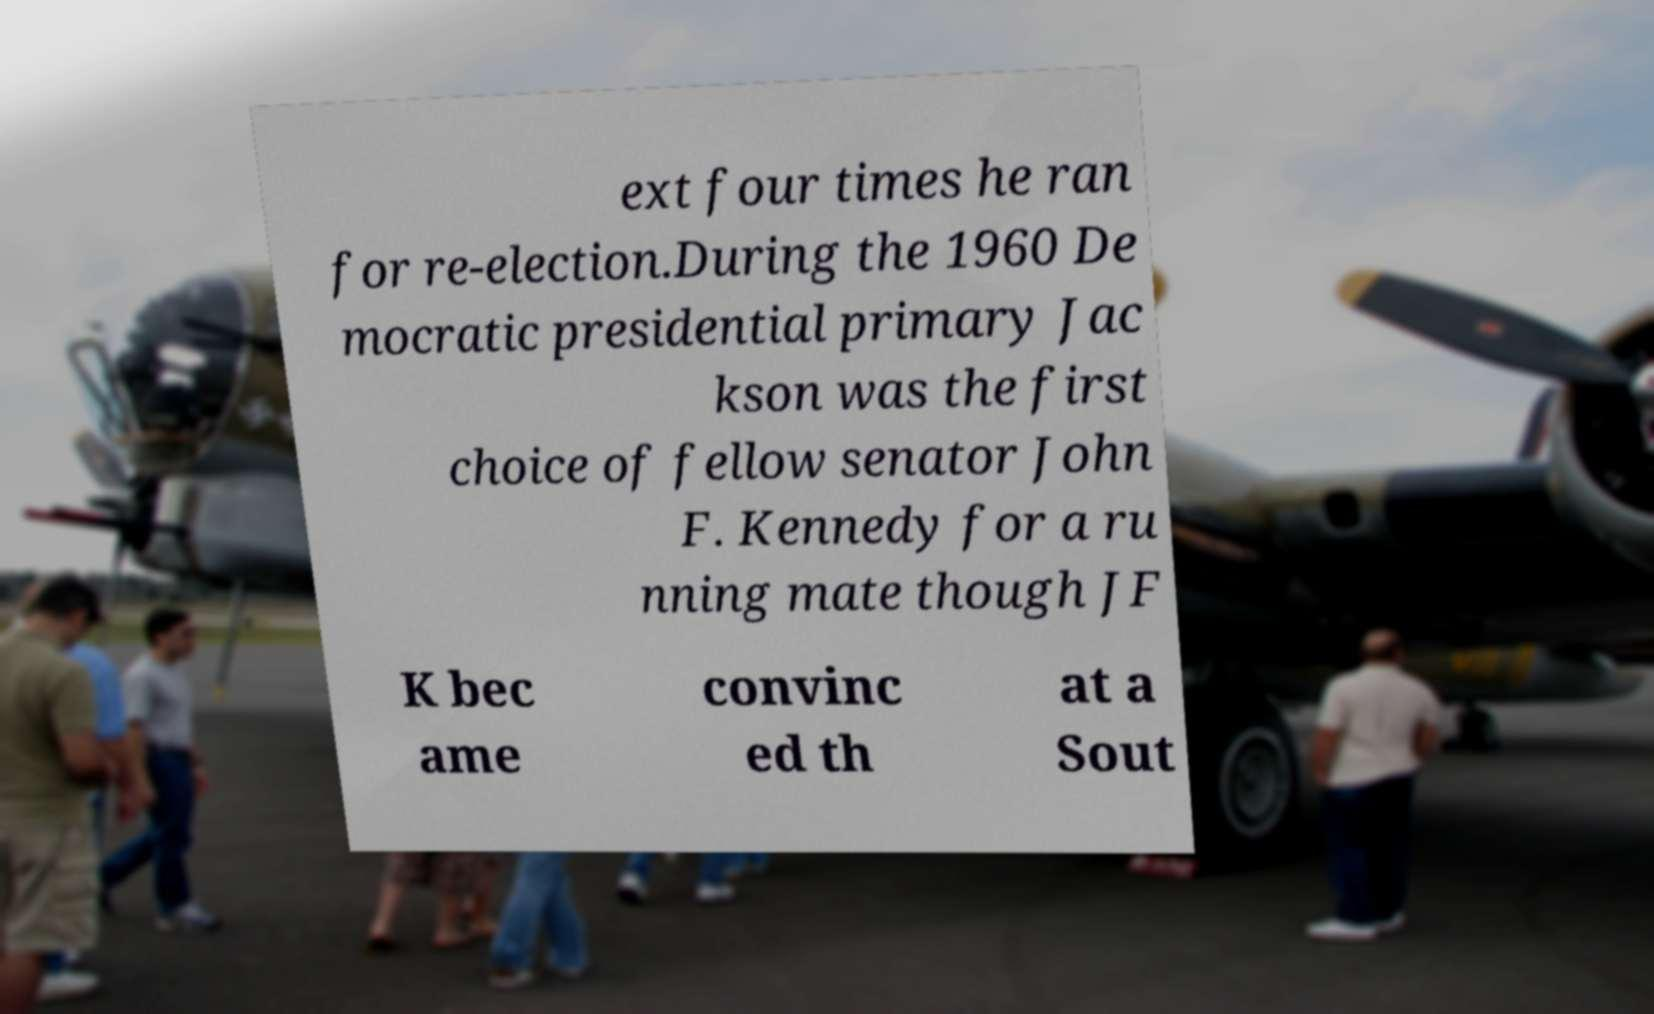I need the written content from this picture converted into text. Can you do that? ext four times he ran for re-election.During the 1960 De mocratic presidential primary Jac kson was the first choice of fellow senator John F. Kennedy for a ru nning mate though JF K bec ame convinc ed th at a Sout 